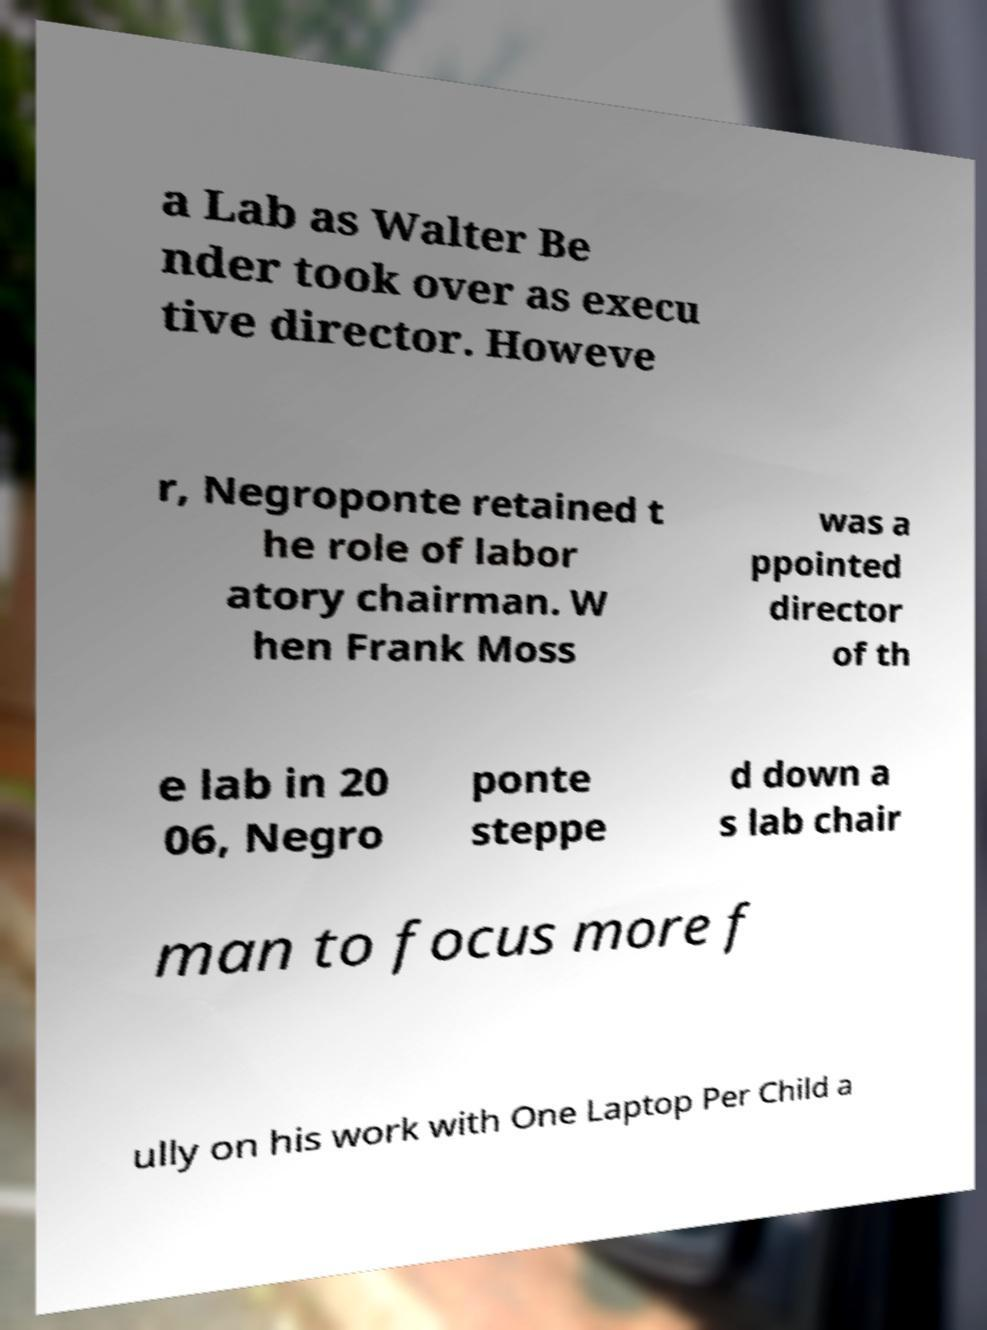For documentation purposes, I need the text within this image transcribed. Could you provide that? a Lab as Walter Be nder took over as execu tive director. Howeve r, Negroponte retained t he role of labor atory chairman. W hen Frank Moss was a ppointed director of th e lab in 20 06, Negro ponte steppe d down a s lab chair man to focus more f ully on his work with One Laptop Per Child a 